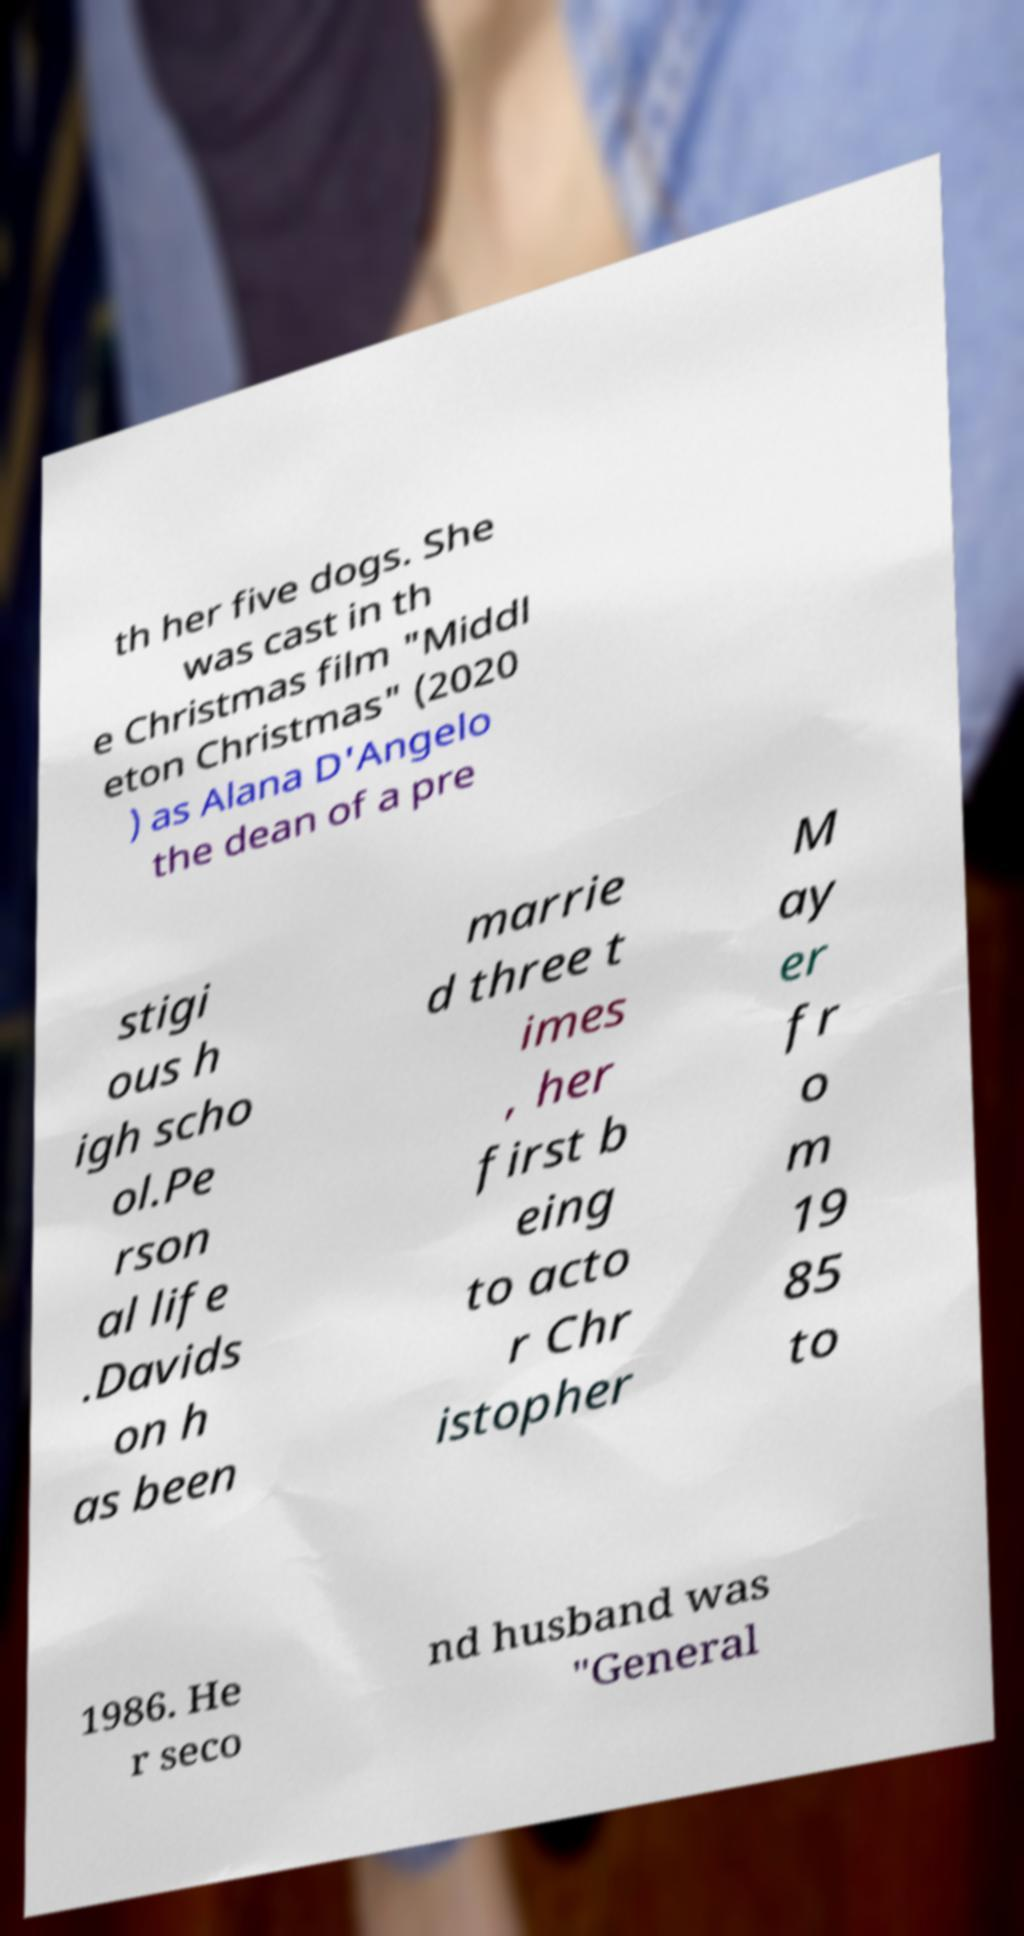Could you assist in decoding the text presented in this image and type it out clearly? th her five dogs. She was cast in th e Christmas film "Middl eton Christmas" (2020 ) as Alana D'Angelo the dean of a pre stigi ous h igh scho ol.Pe rson al life .Davids on h as been marrie d three t imes , her first b eing to acto r Chr istopher M ay er fr o m 19 85 to 1986. He r seco nd husband was "General 